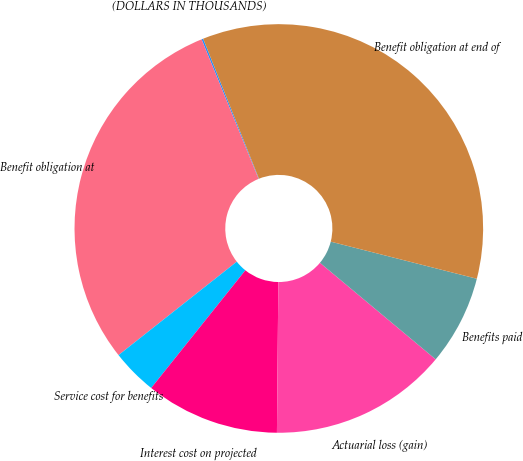Convert chart to OTSL. <chart><loc_0><loc_0><loc_500><loc_500><pie_chart><fcel>(DOLLARS IN THOUSANDS)<fcel>Benefit obligation at<fcel>Service cost for benefits<fcel>Interest cost on projected<fcel>Actuarial loss (gain)<fcel>Benefits paid<fcel>Benefit obligation at end of<nl><fcel>0.13%<fcel>29.47%<fcel>3.62%<fcel>10.59%<fcel>14.08%<fcel>7.11%<fcel>35.0%<nl></chart> 